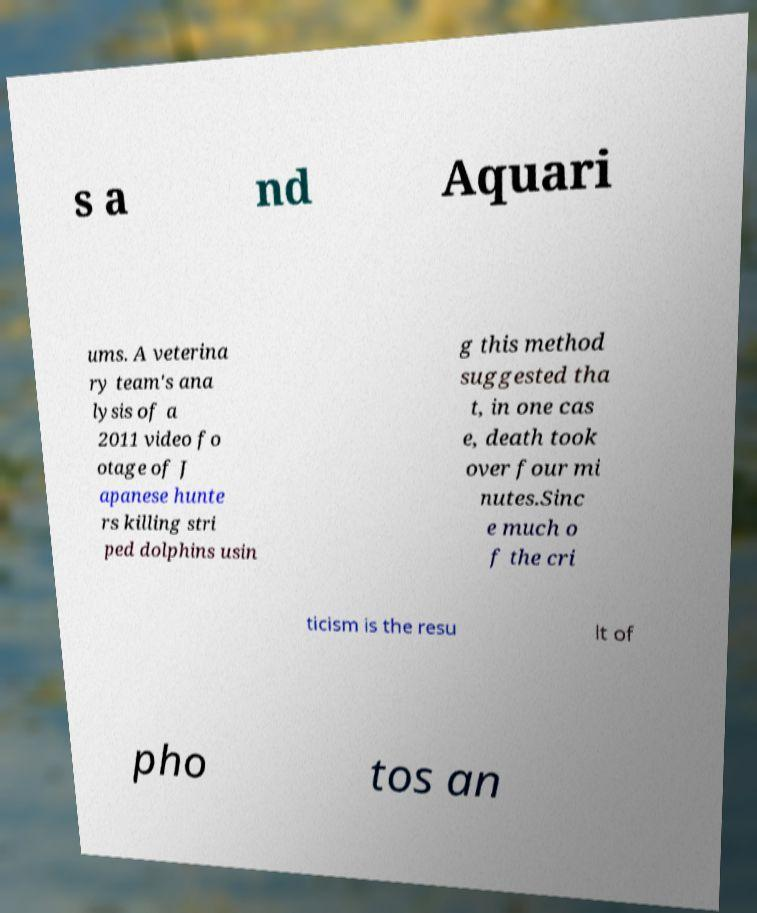Please read and relay the text visible in this image. What does it say? s a nd Aquari ums. A veterina ry team's ana lysis of a 2011 video fo otage of J apanese hunte rs killing stri ped dolphins usin g this method suggested tha t, in one cas e, death took over four mi nutes.Sinc e much o f the cri ticism is the resu lt of pho tos an 